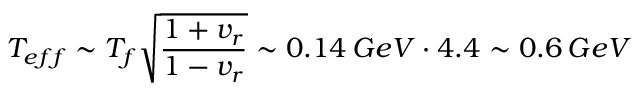<formula> <loc_0><loc_0><loc_500><loc_500>T _ { e f f } \sim T _ { f } \sqrt { \frac { 1 + v _ { r } } { 1 - v _ { r } } } \sim 0 . 1 4 \, G e V \cdot 4 . 4 \sim 0 . 6 \, G e V</formula> 